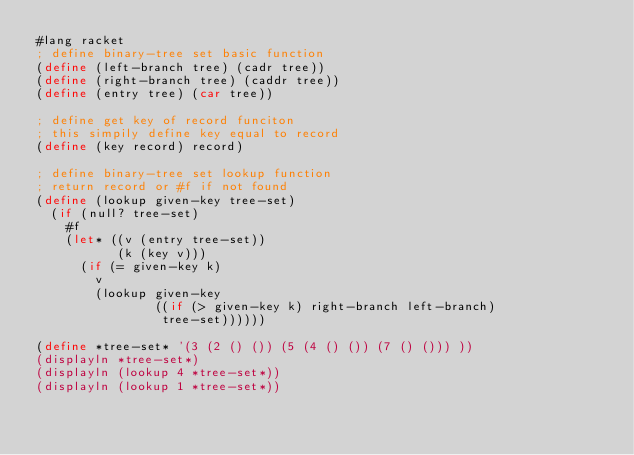Convert code to text. <code><loc_0><loc_0><loc_500><loc_500><_Scheme_>#lang racket
; define binary-tree set basic function
(define (left-branch tree) (cadr tree))
(define (right-branch tree) (caddr tree))
(define (entry tree) (car tree))

; define get key of record funciton
; this simpily define key equal to record
(define (key record) record)

; define binary-tree set lookup function
; return record or #f if not found
(define (lookup given-key tree-set)
  (if (null? tree-set)
    #f
    (let* ((v (entry tree-set))
           (k (key v)))
      (if (= given-key k)
        v
        (lookup given-key
                ((if (> given-key k) right-branch left-branch)
                 tree-set))))))

(define *tree-set* '(3 (2 () ()) (5 (4 () ()) (7 () ())) ))
(displayln *tree-set*)
(displayln (lookup 4 *tree-set*))
(displayln (lookup 1 *tree-set*))
</code> 